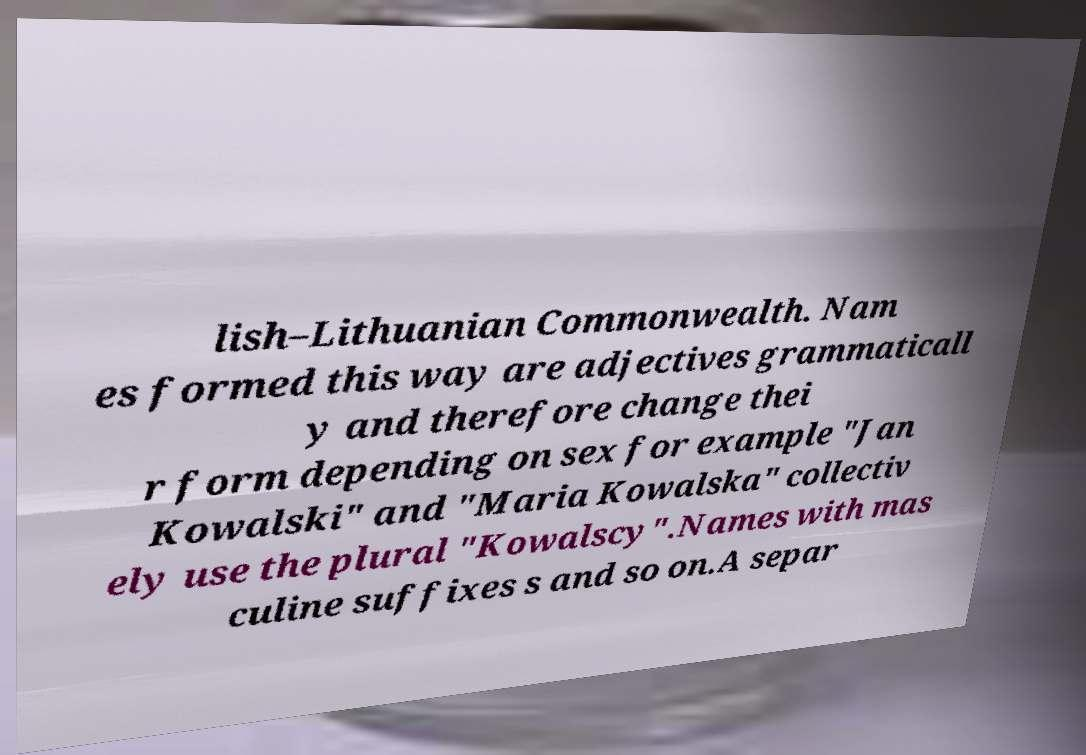There's text embedded in this image that I need extracted. Can you transcribe it verbatim? lish–Lithuanian Commonwealth. Nam es formed this way are adjectives grammaticall y and therefore change thei r form depending on sex for example "Jan Kowalski" and "Maria Kowalska" collectiv ely use the plural "Kowalscy".Names with mas culine suffixes s and so on.A separ 